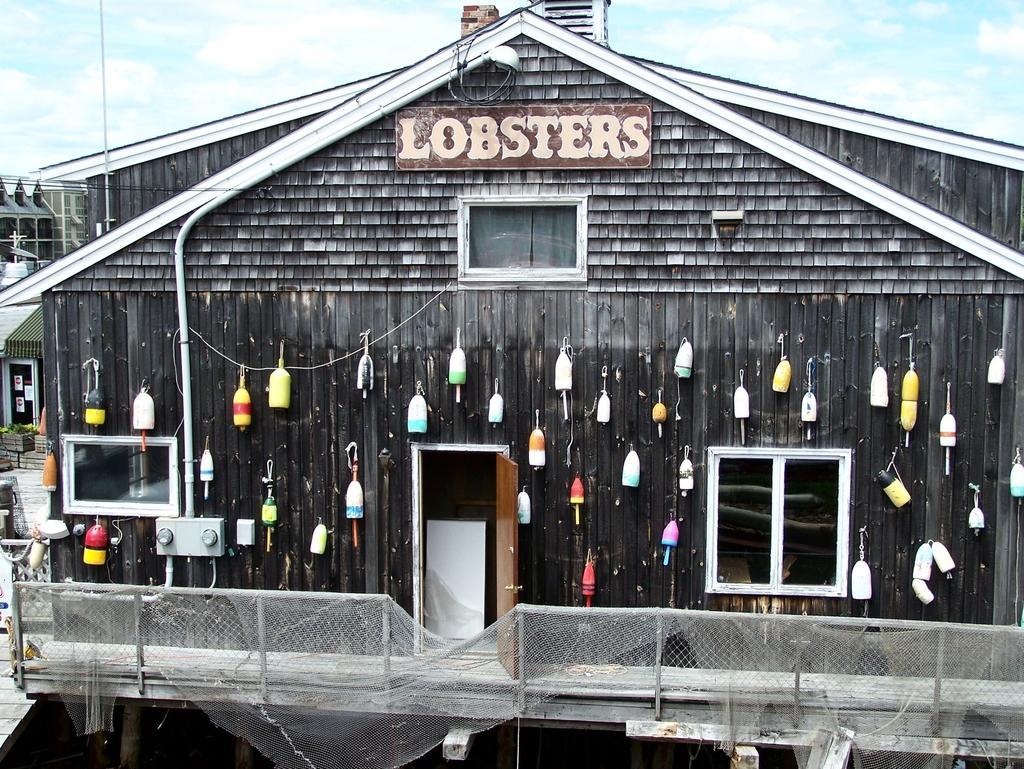Describe this image in one or two sentences. In this image we can see objects are hanging on a house, windows, name board on the wall and a door. At the bottom we can see a net on the railing. In the background we can see houses, objects, poles and clouds in the sky. 